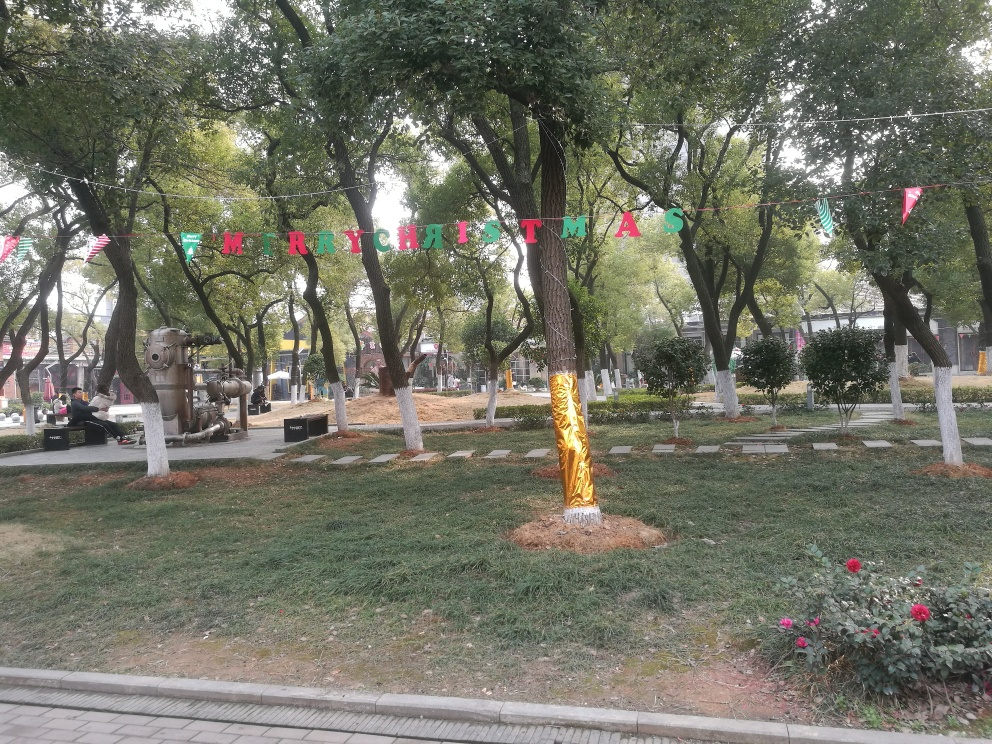What is the weather like in this park scene? The weather in the photo seems mild and pleasant. The sky is overcast, suggesting a cool or temperate day. The full and healthy appearance of the trees, along with the absence of snow or summer sun, indicates it's likely taken during either the spring or autumn seasons. 